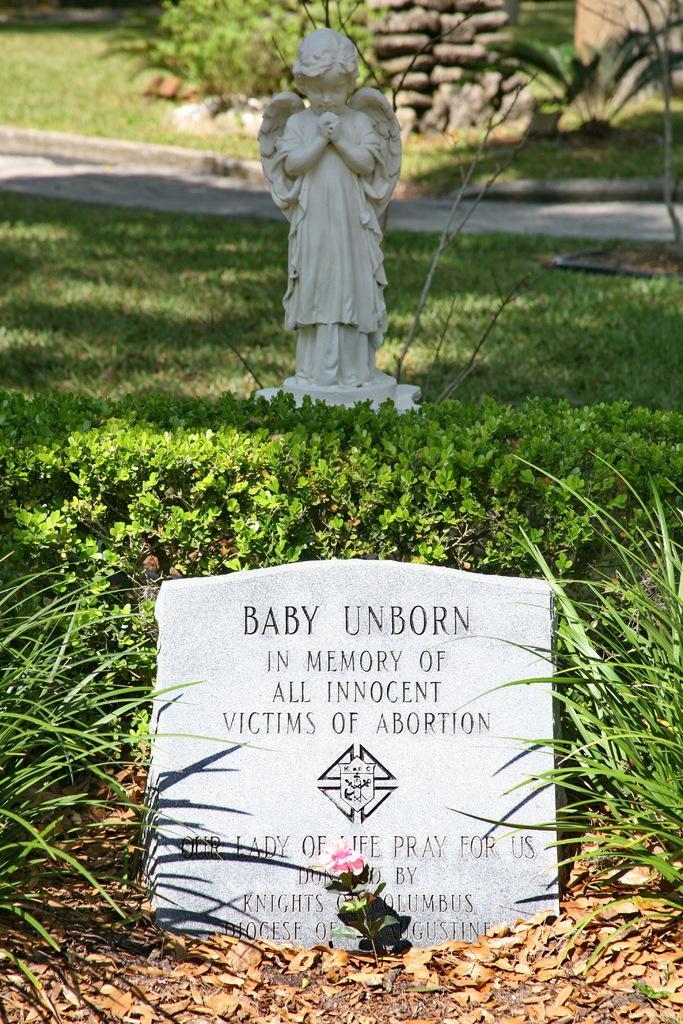In one or two sentences, can you explain what this image depicts? In the picture we can see a gravestone on the grass surface and on it we can see some information and behind it, we can see the sculpture of a person and behind it we can see the plants and some stones. 